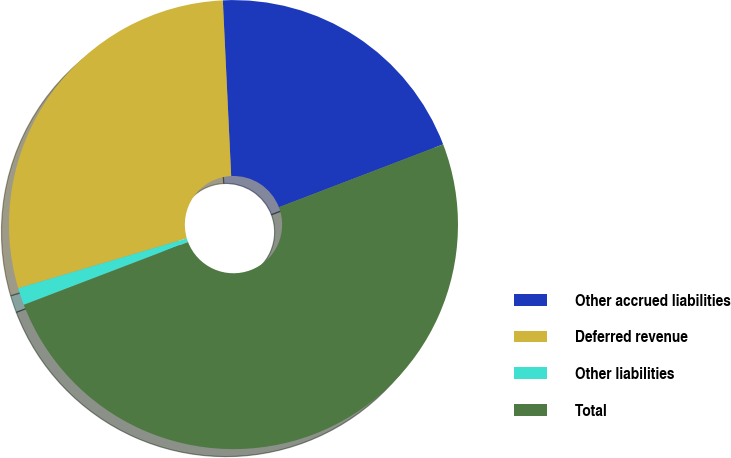Convert chart. <chart><loc_0><loc_0><loc_500><loc_500><pie_chart><fcel>Other accrued liabilities<fcel>Deferred revenue<fcel>Other liabilities<fcel>Total<nl><fcel>19.94%<fcel>28.82%<fcel>1.24%<fcel>50.0%<nl></chart> 